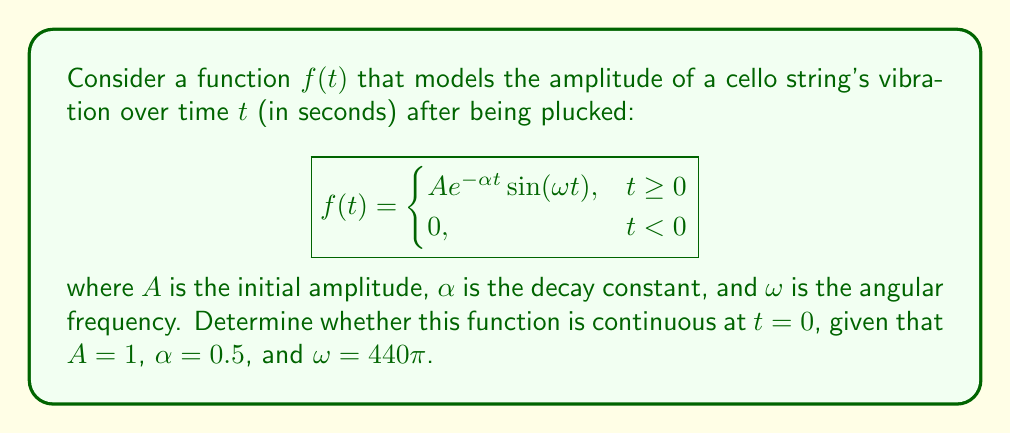Solve this math problem. To determine the continuity of $f(t)$ at $t = 0$, we need to check three conditions:

1. $f(0)$ exists
2. $\lim_{t \to 0^-} f(t)$ exists
3. $\lim_{t \to 0^+} f(t)$ exists
4. All three values are equal

Let's examine each condition:

1. $f(0)$ exists:
   At $t = 0$, we use the top piece of the piecewise function:
   $f(0) = A e^{-\alpha \cdot 0} \sin(\omega \cdot 0) = A \cdot 1 \cdot 0 = 0$

2. $\lim_{t \to 0^-} f(t)$:
   For $t < 0$, $f(t) = 0$, so $\lim_{t \to 0^-} f(t) = 0$

3. $\lim_{t \to 0^+} f(t)$:
   For $t > 0$, we use the top piece of the function:
   $$\lim_{t \to 0^+} f(t) = \lim_{t \to 0^+} A e^{-\alpha t} \sin(\omega t)$$
   
   Using the given values and applying L'Hôpital's rule:
   $$\begin{align}
   \lim_{t \to 0^+} f(t) &= \lim_{t \to 0^+} 1 \cdot e^{-0.5t} \sin(440\pi t) \\
   &= 1 \cdot \lim_{t \to 0^+} \frac{\sin(440\pi t)}{e^{0.5t}} \\
   &= 1 \cdot \lim_{t \to 0^+} \frac{440\pi \cos(440\pi t)}{0.5e^{0.5t}} \\
   &= 1 \cdot \frac{440\pi}{0.5} \cdot \lim_{t \to 0^+} \cos(440\pi t) \\
   &= 880\pi \cdot 1 = 880\pi
   \end{align}$$

4. Comparing the values:
   $f(0) = 0$
   $\lim_{t \to 0^-} f(t) = 0$
   $\lim_{t \to 0^+} f(t) = 880\pi$

Since these three values are not all equal, the function is not continuous at $t = 0$. There is a jump discontinuity at this point.
Answer: The function $f(t)$ is not continuous at $t = 0$. 